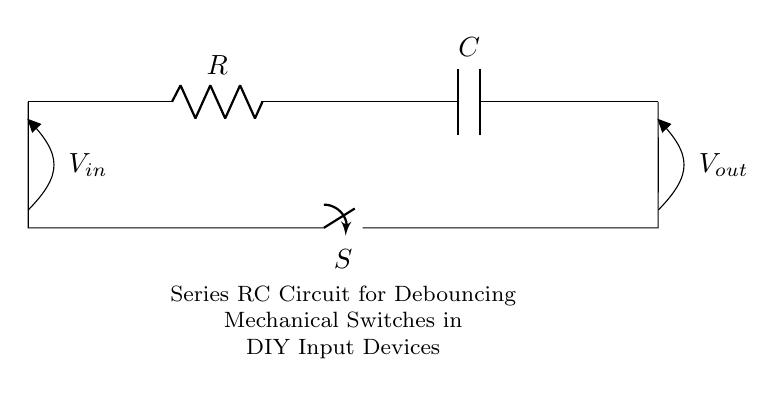What is the value of the resistor? The resistor value is represented as R in the circuit, indicating its role as a resistor in the RC circuit configuration.
Answer: R What type of switch is used in this circuit? The component labeled S indicates that a mechanical switch is used in this circuit to control the flow of current.
Answer: Mechanical switch What does the capacitor do in this circuit? The capacitor labeled C is used to store charge and thus affects the timing characteristics of the debouncing process.
Answer: Store charge How many main components are in the circuit diagram? There are three main components visible in the circuit: a resistor, a capacitor, and a switch, which together form the series RC circuit.
Answer: Three What is measured at the output? The output voltage V_out is measured across the capacitor, which will show the voltage after the switch is toggled.
Answer: V_out Why is this circuit used for debouncing? The series RC circuit smoothes out the rapid on/off signals caused by mechanical switch bounce, providing a stable output as a result.
Answer: Smoothes signals What happens to the output voltage when the switch is closed? When the switch is closed, the output voltage V_out rises as the capacitor charges through the resistor, defined by the time constant of the circuit.
Answer: Rises 